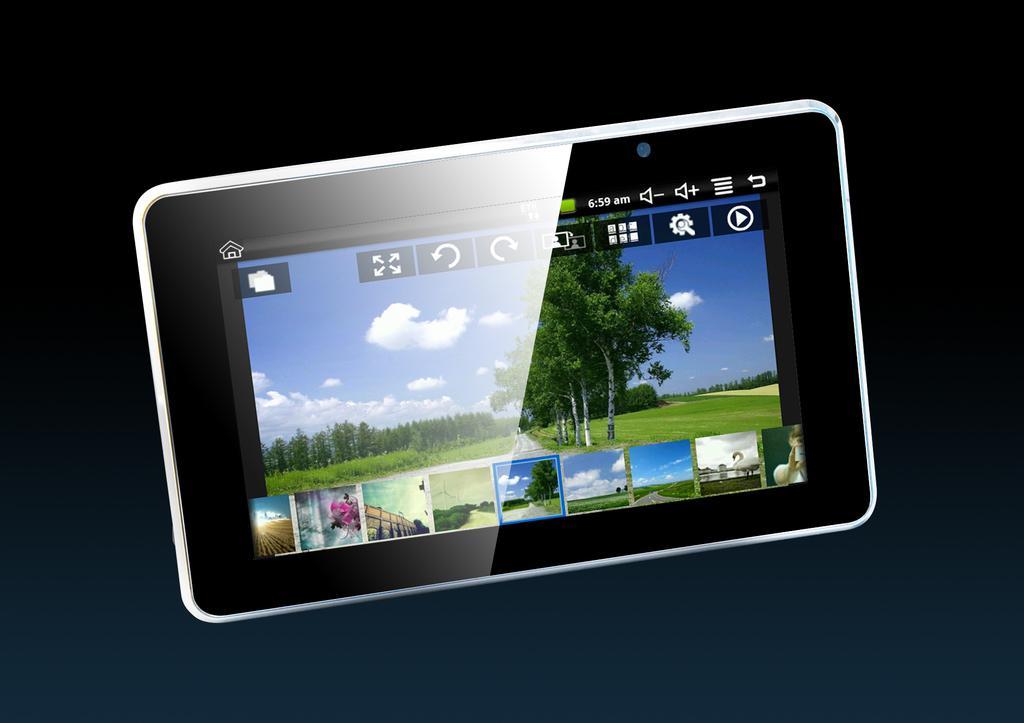Please provide a concise description of this image. There is a tab having a screen in which, there is a menu, a wallpaper, trees, clouds and grass on the ground. And there are small images. Outside this tab, the background is dark in color. 